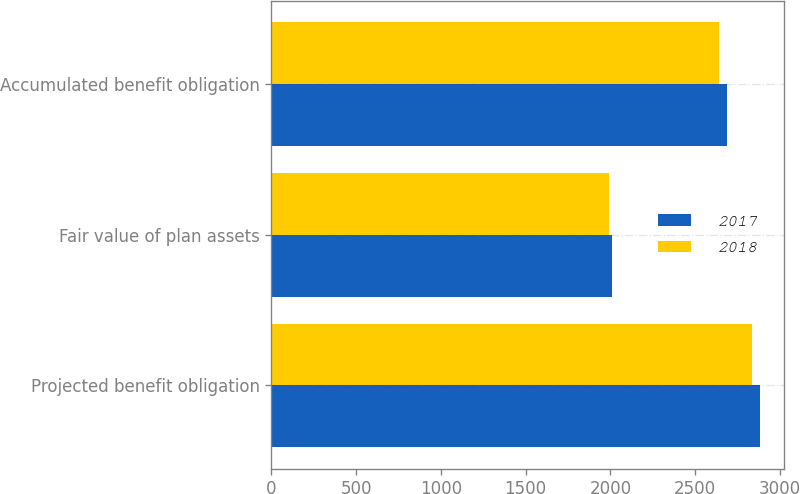<chart> <loc_0><loc_0><loc_500><loc_500><stacked_bar_chart><ecel><fcel>Projected benefit obligation<fcel>Fair value of plan assets<fcel>Accumulated benefit obligation<nl><fcel>2017<fcel>2882<fcel>2007<fcel>2689<nl><fcel>2018<fcel>2834<fcel>1992<fcel>2641<nl></chart> 